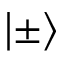<formula> <loc_0><loc_0><loc_500><loc_500>| \pm \rangle</formula> 